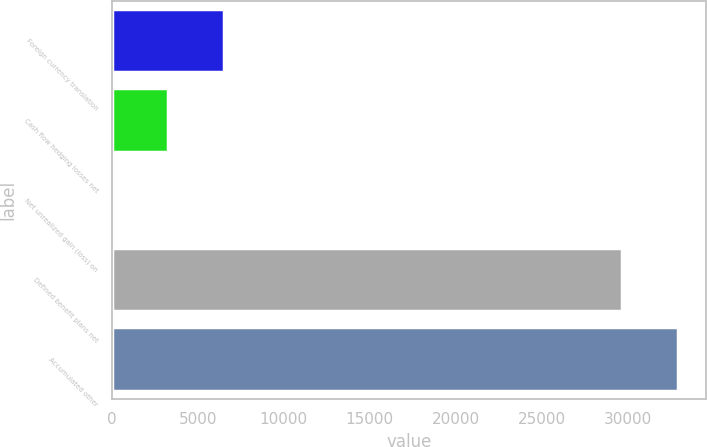Convert chart to OTSL. <chart><loc_0><loc_0><loc_500><loc_500><bar_chart><fcel>Foreign currency translation<fcel>Cash flow hedging losses net<fcel>Net unrealized gain (loss) on<fcel>Defined benefit plans net<fcel>Accumulated other<nl><fcel>6494.2<fcel>3263.6<fcel>33<fcel>29694<fcel>32924.6<nl></chart> 